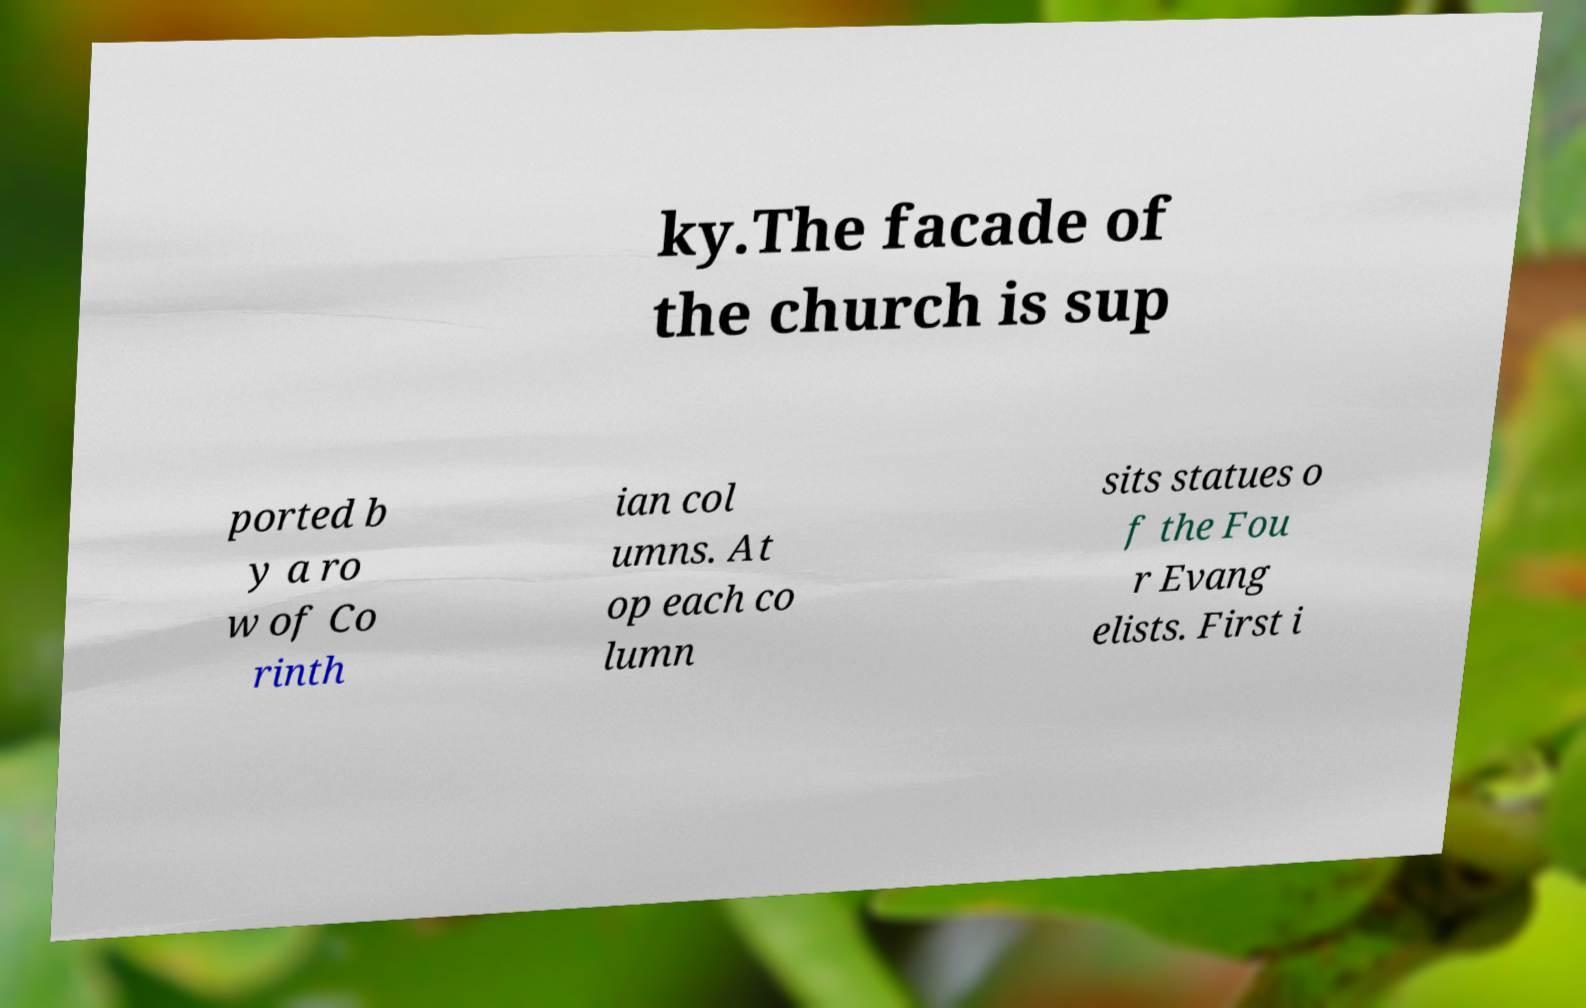Can you read and provide the text displayed in the image?This photo seems to have some interesting text. Can you extract and type it out for me? ky.The facade of the church is sup ported b y a ro w of Co rinth ian col umns. At op each co lumn sits statues o f the Fou r Evang elists. First i 